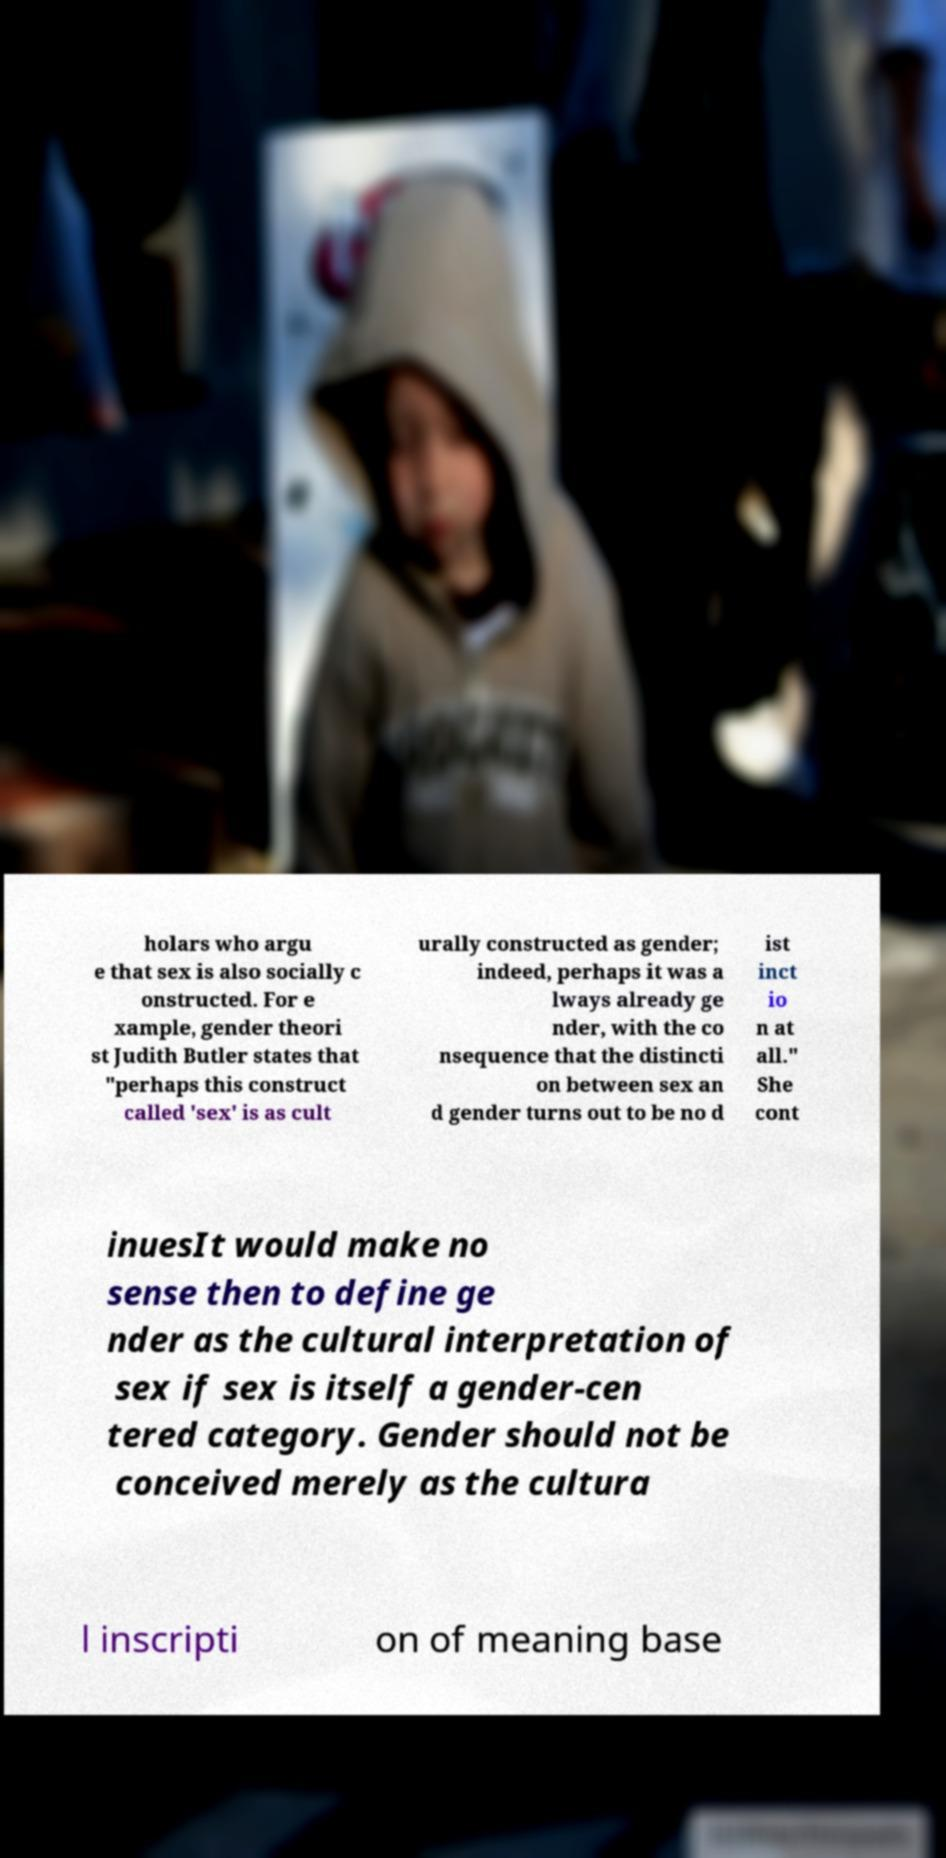Could you extract and type out the text from this image? holars who argu e that sex is also socially c onstructed. For e xample, gender theori st Judith Butler states that "perhaps this construct called 'sex' is as cult urally constructed as gender; indeed, perhaps it was a lways already ge nder, with the co nsequence that the distincti on between sex an d gender turns out to be no d ist inct io n at all." She cont inuesIt would make no sense then to define ge nder as the cultural interpretation of sex if sex is itself a gender-cen tered category. Gender should not be conceived merely as the cultura l inscripti on of meaning base 